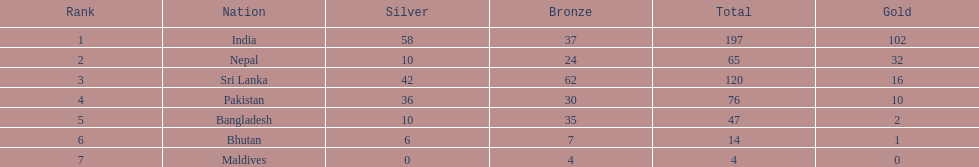What were the total amount won of medals by nations in the 1999 south asian games? 197, 65, 120, 76, 47, 14, 4. Which amount was the lowest? 4. Which nation had this amount? Maldives. 